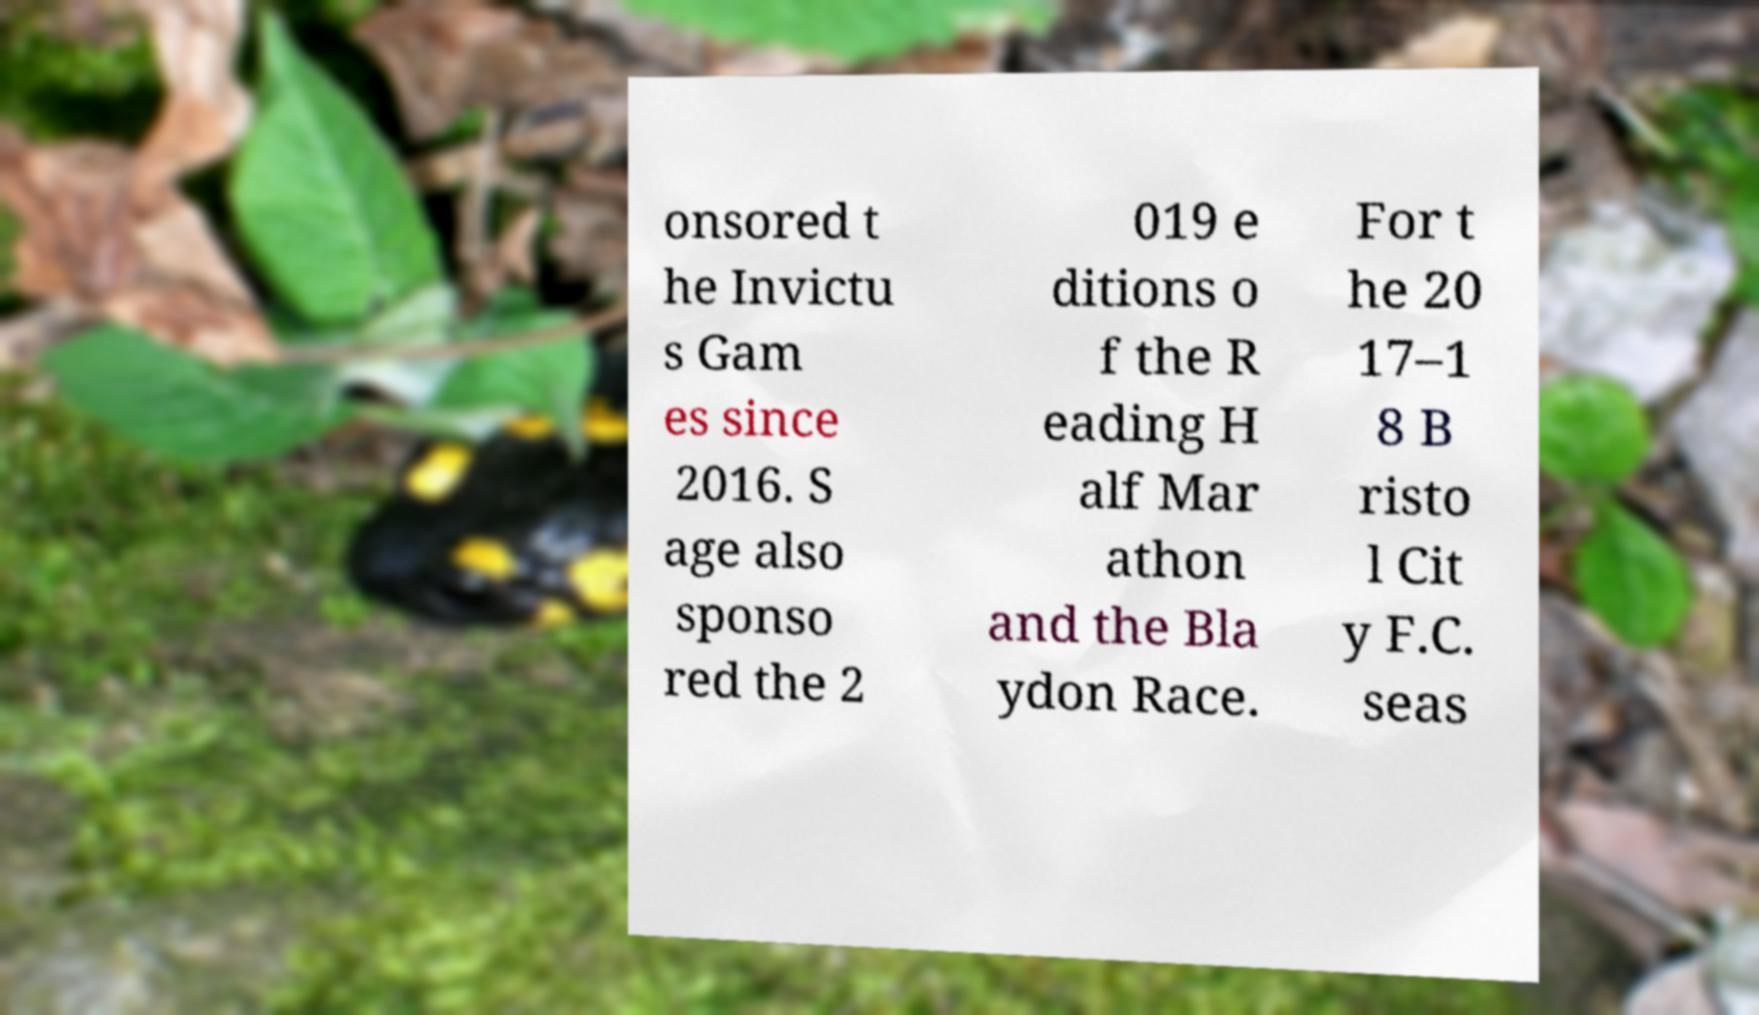Could you assist in decoding the text presented in this image and type it out clearly? onsored t he Invictu s Gam es since 2016. S age also sponso red the 2 019 e ditions o f the R eading H alf Mar athon and the Bla ydon Race. For t he 20 17–1 8 B risto l Cit y F.C. seas 